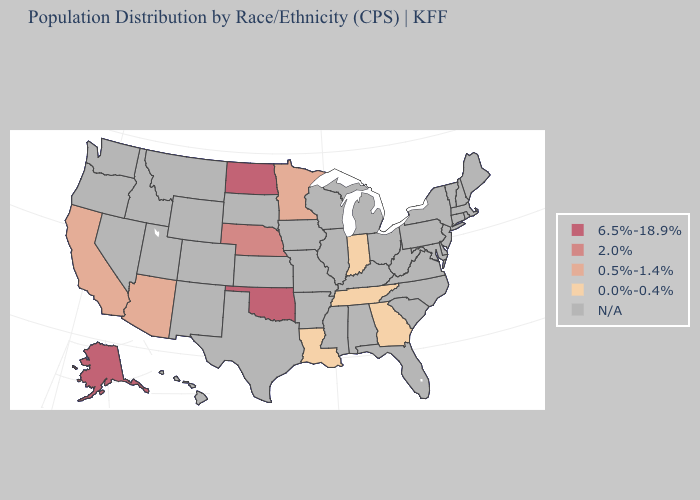Is the legend a continuous bar?
Concise answer only. No. Name the states that have a value in the range 6.5%-18.9%?
Write a very short answer. Alaska, North Dakota, Oklahoma. What is the highest value in the USA?
Answer briefly. 6.5%-18.9%. Name the states that have a value in the range 6.5%-18.9%?
Quick response, please. Alaska, North Dakota, Oklahoma. What is the highest value in the USA?
Give a very brief answer. 6.5%-18.9%. Among the states that border Iowa , does Nebraska have the highest value?
Be succinct. Yes. What is the value of New Jersey?
Keep it brief. N/A. What is the lowest value in states that border North Dakota?
Concise answer only. 0.5%-1.4%. Among the states that border North Dakota , which have the lowest value?
Short answer required. Minnesota. Is the legend a continuous bar?
Answer briefly. No. Which states have the highest value in the USA?
Write a very short answer. Alaska, North Dakota, Oklahoma. What is the value of Vermont?
Write a very short answer. N/A. Does the map have missing data?
Be succinct. Yes. What is the value of South Dakota?
Concise answer only. N/A. 